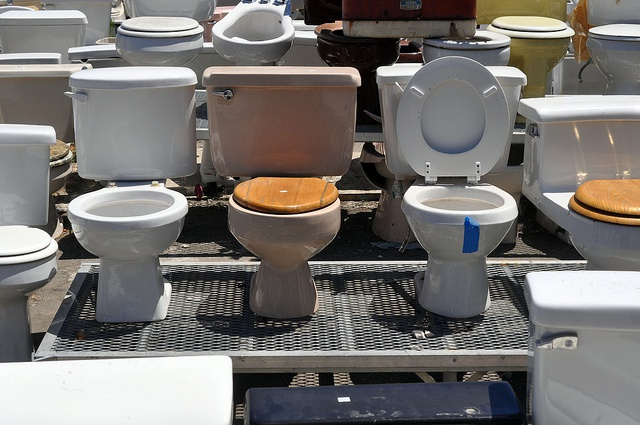Describe the objects in this image and their specific colors. I can see toilet in lightgray, gray, maroon, and orange tones, toilet in lightgray, gray, darkgray, white, and black tones, toilet in lightgray, gray, and darkgray tones, toilet in lightgray, gray, white, and tan tones, and toilet in lightgray, gray, and white tones in this image. 